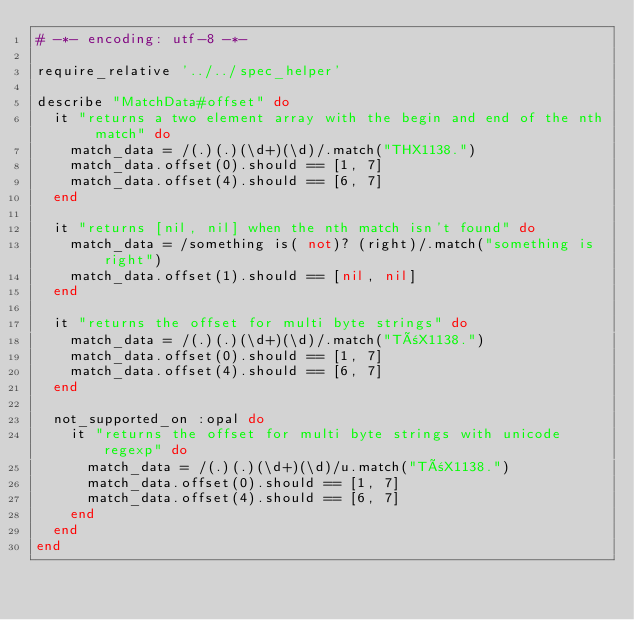Convert code to text. <code><loc_0><loc_0><loc_500><loc_500><_Ruby_># -*- encoding: utf-8 -*-

require_relative '../../spec_helper'

describe "MatchData#offset" do
  it "returns a two element array with the begin and end of the nth match" do
    match_data = /(.)(.)(\d+)(\d)/.match("THX1138.")
    match_data.offset(0).should == [1, 7]
    match_data.offset(4).should == [6, 7]
  end

  it "returns [nil, nil] when the nth match isn't found" do
    match_data = /something is( not)? (right)/.match("something is right")
    match_data.offset(1).should == [nil, nil]
  end

  it "returns the offset for multi byte strings" do
    match_data = /(.)(.)(\d+)(\d)/.match("TñX1138.")
    match_data.offset(0).should == [1, 7]
    match_data.offset(4).should == [6, 7]
  end

  not_supported_on :opal do
    it "returns the offset for multi byte strings with unicode regexp" do
      match_data = /(.)(.)(\d+)(\d)/u.match("TñX1138.")
      match_data.offset(0).should == [1, 7]
      match_data.offset(4).should == [6, 7]
    end
  end
end
</code> 